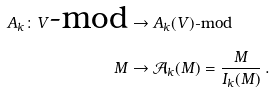Convert formula to latex. <formula><loc_0><loc_0><loc_500><loc_500>A _ { k } \colon V \text {-mod} & \rightarrow A _ { k } ( V ) \text {-mod} \\ M & \rightarrow \mathcal { A } _ { k } ( M ) = \frac { M } { I _ { k } ( M ) } \, .</formula> 